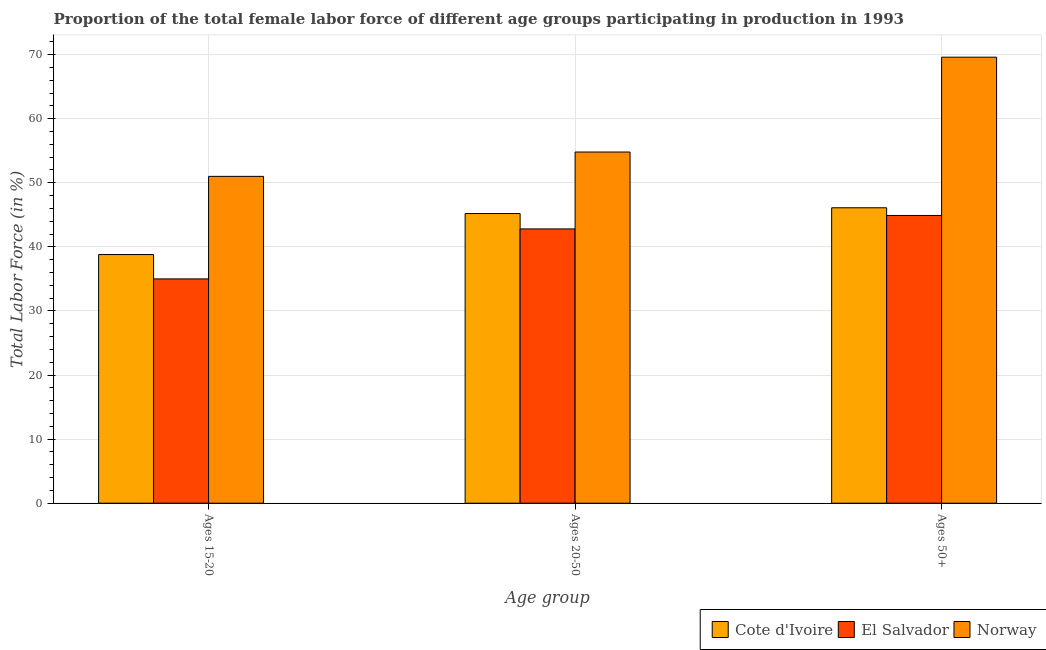How many different coloured bars are there?
Give a very brief answer. 3. How many groups of bars are there?
Your answer should be compact. 3. Are the number of bars on each tick of the X-axis equal?
Keep it short and to the point. Yes. How many bars are there on the 3rd tick from the left?
Your answer should be very brief. 3. How many bars are there on the 1st tick from the right?
Keep it short and to the point. 3. What is the label of the 3rd group of bars from the left?
Keep it short and to the point. Ages 50+. What is the percentage of female labor force within the age group 20-50 in El Salvador?
Keep it short and to the point. 42.8. Across all countries, what is the maximum percentage of female labor force above age 50?
Make the answer very short. 69.6. Across all countries, what is the minimum percentage of female labor force within the age group 20-50?
Your answer should be compact. 42.8. In which country was the percentage of female labor force within the age group 15-20 minimum?
Keep it short and to the point. El Salvador. What is the total percentage of female labor force within the age group 20-50 in the graph?
Ensure brevity in your answer.  142.8. What is the difference between the percentage of female labor force within the age group 20-50 in Norway and that in Cote d'Ivoire?
Your answer should be very brief. 9.6. What is the difference between the percentage of female labor force above age 50 in Cote d'Ivoire and the percentage of female labor force within the age group 20-50 in El Salvador?
Your response must be concise. 3.3. What is the average percentage of female labor force within the age group 15-20 per country?
Ensure brevity in your answer.  41.6. What is the difference between the percentage of female labor force above age 50 and percentage of female labor force within the age group 15-20 in El Salvador?
Ensure brevity in your answer.  9.9. What is the ratio of the percentage of female labor force above age 50 in Cote d'Ivoire to that in El Salvador?
Give a very brief answer. 1.03. Is the percentage of female labor force within the age group 15-20 in Norway less than that in El Salvador?
Offer a terse response. No. Is the difference between the percentage of female labor force above age 50 in Cote d'Ivoire and El Salvador greater than the difference between the percentage of female labor force within the age group 20-50 in Cote d'Ivoire and El Salvador?
Offer a terse response. No. What is the difference between the highest and the second highest percentage of female labor force above age 50?
Your response must be concise. 23.5. In how many countries, is the percentage of female labor force within the age group 20-50 greater than the average percentage of female labor force within the age group 20-50 taken over all countries?
Make the answer very short. 1. What does the 2nd bar from the left in Ages 50+ represents?
Provide a short and direct response. El Salvador. Is it the case that in every country, the sum of the percentage of female labor force within the age group 15-20 and percentage of female labor force within the age group 20-50 is greater than the percentage of female labor force above age 50?
Provide a short and direct response. Yes. How many bars are there?
Your answer should be very brief. 9. Are all the bars in the graph horizontal?
Your response must be concise. No. What is the difference between two consecutive major ticks on the Y-axis?
Your answer should be compact. 10. Are the values on the major ticks of Y-axis written in scientific E-notation?
Ensure brevity in your answer.  No. Does the graph contain any zero values?
Your answer should be very brief. No. Where does the legend appear in the graph?
Provide a short and direct response. Bottom right. How many legend labels are there?
Ensure brevity in your answer.  3. What is the title of the graph?
Your answer should be compact. Proportion of the total female labor force of different age groups participating in production in 1993. What is the label or title of the X-axis?
Your answer should be very brief. Age group. What is the Total Labor Force (in %) in Cote d'Ivoire in Ages 15-20?
Offer a terse response. 38.8. What is the Total Labor Force (in %) in Norway in Ages 15-20?
Offer a terse response. 51. What is the Total Labor Force (in %) in Cote d'Ivoire in Ages 20-50?
Ensure brevity in your answer.  45.2. What is the Total Labor Force (in %) of El Salvador in Ages 20-50?
Offer a very short reply. 42.8. What is the Total Labor Force (in %) of Norway in Ages 20-50?
Make the answer very short. 54.8. What is the Total Labor Force (in %) in Cote d'Ivoire in Ages 50+?
Make the answer very short. 46.1. What is the Total Labor Force (in %) of El Salvador in Ages 50+?
Give a very brief answer. 44.9. What is the Total Labor Force (in %) of Norway in Ages 50+?
Give a very brief answer. 69.6. Across all Age group, what is the maximum Total Labor Force (in %) of Cote d'Ivoire?
Provide a succinct answer. 46.1. Across all Age group, what is the maximum Total Labor Force (in %) of El Salvador?
Provide a succinct answer. 44.9. Across all Age group, what is the maximum Total Labor Force (in %) of Norway?
Provide a short and direct response. 69.6. Across all Age group, what is the minimum Total Labor Force (in %) in Cote d'Ivoire?
Offer a very short reply. 38.8. What is the total Total Labor Force (in %) in Cote d'Ivoire in the graph?
Your response must be concise. 130.1. What is the total Total Labor Force (in %) of El Salvador in the graph?
Make the answer very short. 122.7. What is the total Total Labor Force (in %) in Norway in the graph?
Offer a terse response. 175.4. What is the difference between the Total Labor Force (in %) in Cote d'Ivoire in Ages 15-20 and that in Ages 20-50?
Offer a very short reply. -6.4. What is the difference between the Total Labor Force (in %) of El Salvador in Ages 15-20 and that in Ages 20-50?
Make the answer very short. -7.8. What is the difference between the Total Labor Force (in %) of Cote d'Ivoire in Ages 15-20 and that in Ages 50+?
Your response must be concise. -7.3. What is the difference between the Total Labor Force (in %) of Norway in Ages 15-20 and that in Ages 50+?
Provide a short and direct response. -18.6. What is the difference between the Total Labor Force (in %) of Norway in Ages 20-50 and that in Ages 50+?
Give a very brief answer. -14.8. What is the difference between the Total Labor Force (in %) of Cote d'Ivoire in Ages 15-20 and the Total Labor Force (in %) of El Salvador in Ages 20-50?
Make the answer very short. -4. What is the difference between the Total Labor Force (in %) of El Salvador in Ages 15-20 and the Total Labor Force (in %) of Norway in Ages 20-50?
Your answer should be compact. -19.8. What is the difference between the Total Labor Force (in %) of Cote d'Ivoire in Ages 15-20 and the Total Labor Force (in %) of El Salvador in Ages 50+?
Provide a succinct answer. -6.1. What is the difference between the Total Labor Force (in %) in Cote d'Ivoire in Ages 15-20 and the Total Labor Force (in %) in Norway in Ages 50+?
Your answer should be very brief. -30.8. What is the difference between the Total Labor Force (in %) of El Salvador in Ages 15-20 and the Total Labor Force (in %) of Norway in Ages 50+?
Ensure brevity in your answer.  -34.6. What is the difference between the Total Labor Force (in %) of Cote d'Ivoire in Ages 20-50 and the Total Labor Force (in %) of El Salvador in Ages 50+?
Provide a succinct answer. 0.3. What is the difference between the Total Labor Force (in %) in Cote d'Ivoire in Ages 20-50 and the Total Labor Force (in %) in Norway in Ages 50+?
Your answer should be compact. -24.4. What is the difference between the Total Labor Force (in %) in El Salvador in Ages 20-50 and the Total Labor Force (in %) in Norway in Ages 50+?
Keep it short and to the point. -26.8. What is the average Total Labor Force (in %) of Cote d'Ivoire per Age group?
Your answer should be very brief. 43.37. What is the average Total Labor Force (in %) in El Salvador per Age group?
Your answer should be very brief. 40.9. What is the average Total Labor Force (in %) of Norway per Age group?
Offer a very short reply. 58.47. What is the difference between the Total Labor Force (in %) of Cote d'Ivoire and Total Labor Force (in %) of Norway in Ages 15-20?
Give a very brief answer. -12.2. What is the difference between the Total Labor Force (in %) of El Salvador and Total Labor Force (in %) of Norway in Ages 15-20?
Provide a succinct answer. -16. What is the difference between the Total Labor Force (in %) in Cote d'Ivoire and Total Labor Force (in %) in Norway in Ages 20-50?
Your answer should be compact. -9.6. What is the difference between the Total Labor Force (in %) of Cote d'Ivoire and Total Labor Force (in %) of Norway in Ages 50+?
Give a very brief answer. -23.5. What is the difference between the Total Labor Force (in %) in El Salvador and Total Labor Force (in %) in Norway in Ages 50+?
Keep it short and to the point. -24.7. What is the ratio of the Total Labor Force (in %) in Cote d'Ivoire in Ages 15-20 to that in Ages 20-50?
Ensure brevity in your answer.  0.86. What is the ratio of the Total Labor Force (in %) of El Salvador in Ages 15-20 to that in Ages 20-50?
Your answer should be compact. 0.82. What is the ratio of the Total Labor Force (in %) in Norway in Ages 15-20 to that in Ages 20-50?
Your response must be concise. 0.93. What is the ratio of the Total Labor Force (in %) of Cote d'Ivoire in Ages 15-20 to that in Ages 50+?
Make the answer very short. 0.84. What is the ratio of the Total Labor Force (in %) of El Salvador in Ages 15-20 to that in Ages 50+?
Offer a terse response. 0.78. What is the ratio of the Total Labor Force (in %) of Norway in Ages 15-20 to that in Ages 50+?
Your answer should be compact. 0.73. What is the ratio of the Total Labor Force (in %) in Cote d'Ivoire in Ages 20-50 to that in Ages 50+?
Your response must be concise. 0.98. What is the ratio of the Total Labor Force (in %) in El Salvador in Ages 20-50 to that in Ages 50+?
Your response must be concise. 0.95. What is the ratio of the Total Labor Force (in %) of Norway in Ages 20-50 to that in Ages 50+?
Offer a very short reply. 0.79. What is the difference between the highest and the second highest Total Labor Force (in %) in Cote d'Ivoire?
Provide a succinct answer. 0.9. What is the difference between the highest and the second highest Total Labor Force (in %) of El Salvador?
Your answer should be compact. 2.1. What is the difference between the highest and the second highest Total Labor Force (in %) of Norway?
Offer a terse response. 14.8. What is the difference between the highest and the lowest Total Labor Force (in %) in Cote d'Ivoire?
Your answer should be very brief. 7.3. What is the difference between the highest and the lowest Total Labor Force (in %) in El Salvador?
Provide a succinct answer. 9.9. What is the difference between the highest and the lowest Total Labor Force (in %) in Norway?
Offer a terse response. 18.6. 